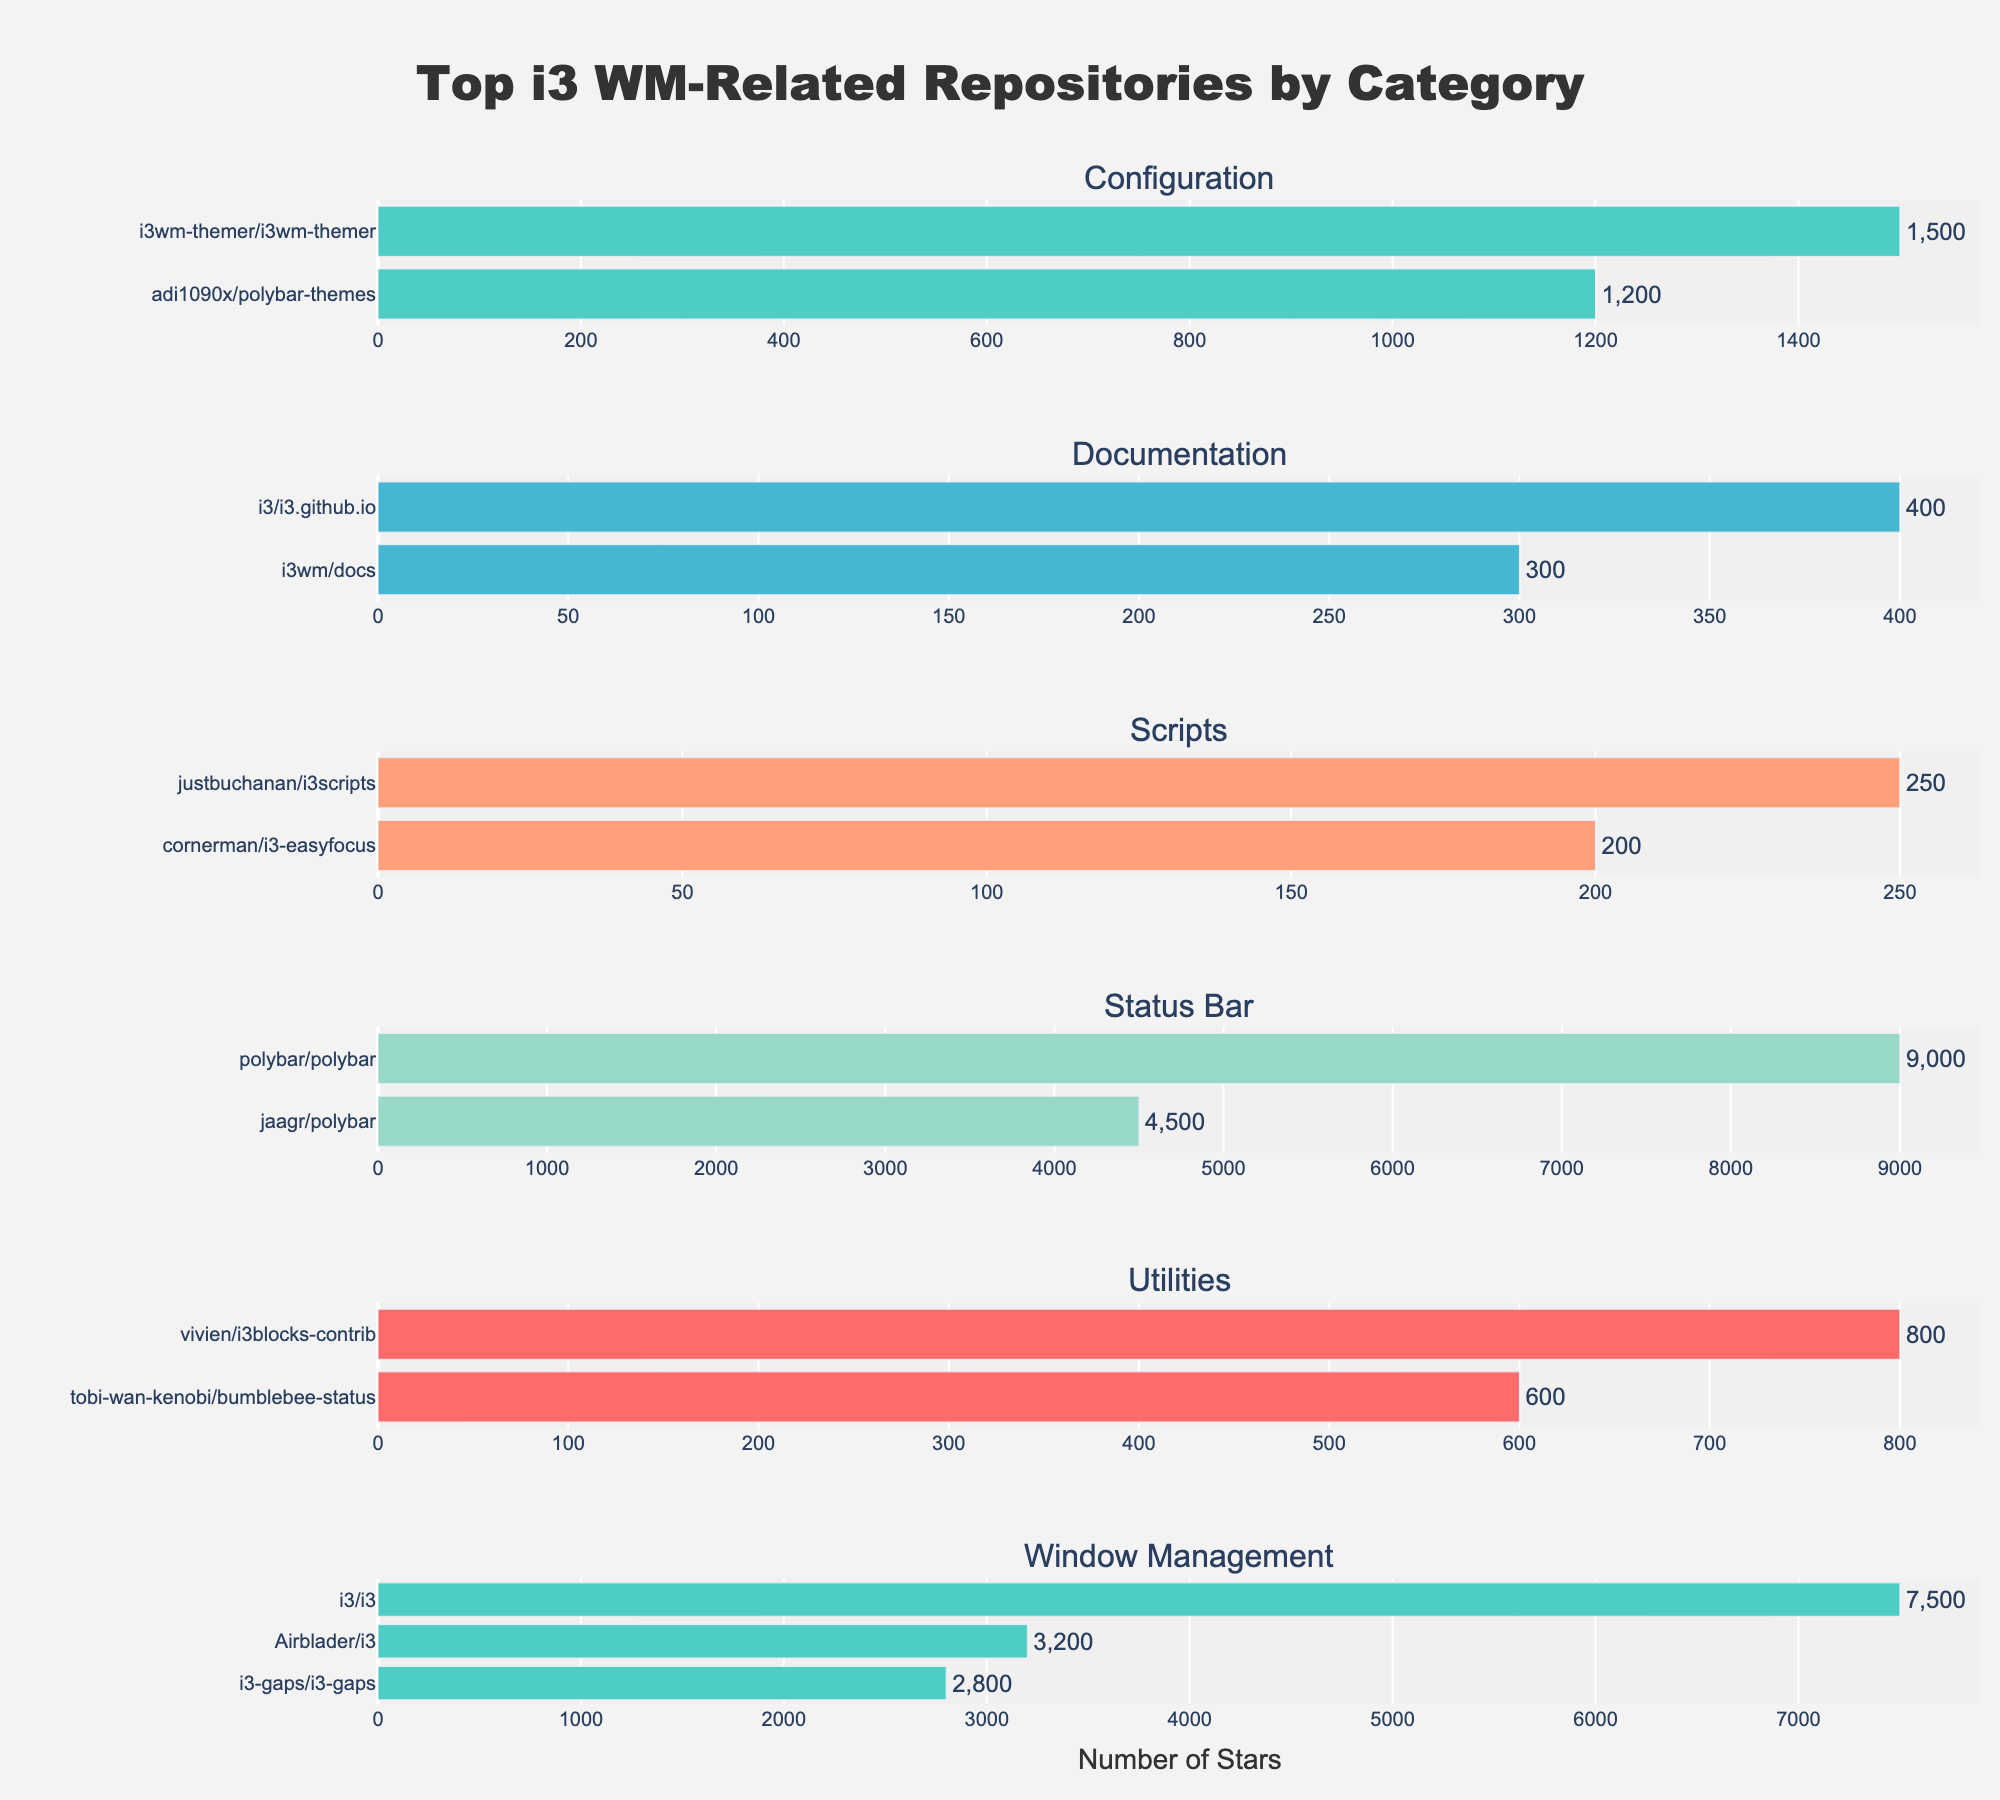What's the highest frequency note used in Rock? By interpreting the Rock subplot, identify the highest bar. The note with the tallest bar has the highest frequency. The highest bar in Rock corresponds to note C.
Answer: C What's the total frequency percentage of notes E and F in Classical? Locate the frequencies of notes E and F in the Classical genre subplot. Sum these two percentages: 14.7 (E) + 8.9 (F) = 23.6.
Answer: 23.6 Which genre has the lowest frequency of note G#? Inspect the subplots and find the bar indicating note G# for each genre. The genre with the shortest bar for G# is Blues with a frequency of 2.5%.
Answer: Blues What's the average frequency for notes A and A# across all genres? Add the frequencies for notes A and A# across all subplots and then divide by the number of genres (6). For A: 11.8 + 9.5 + 8.6 + 5.6 + 13.7 + 9.7 = 58.9. For A#: 2.7 + 5.3 + 3.1 + 8.1 + 4.2 + 3.8 = 27.2. Their averages: A: 58.9/6 ≈ 9.82 and A#: 27.2/6 ≈ 4.53.
Answer: A: 9.82, A#: 4.53 Which genre has the most balanced distribution (least variance) of note frequencies? To identify the most balanced distribution, visually inspect each subplot for even bar heights. Electronic appears to have the most evenly distributed frequencies across notes.
Answer: Electronic 